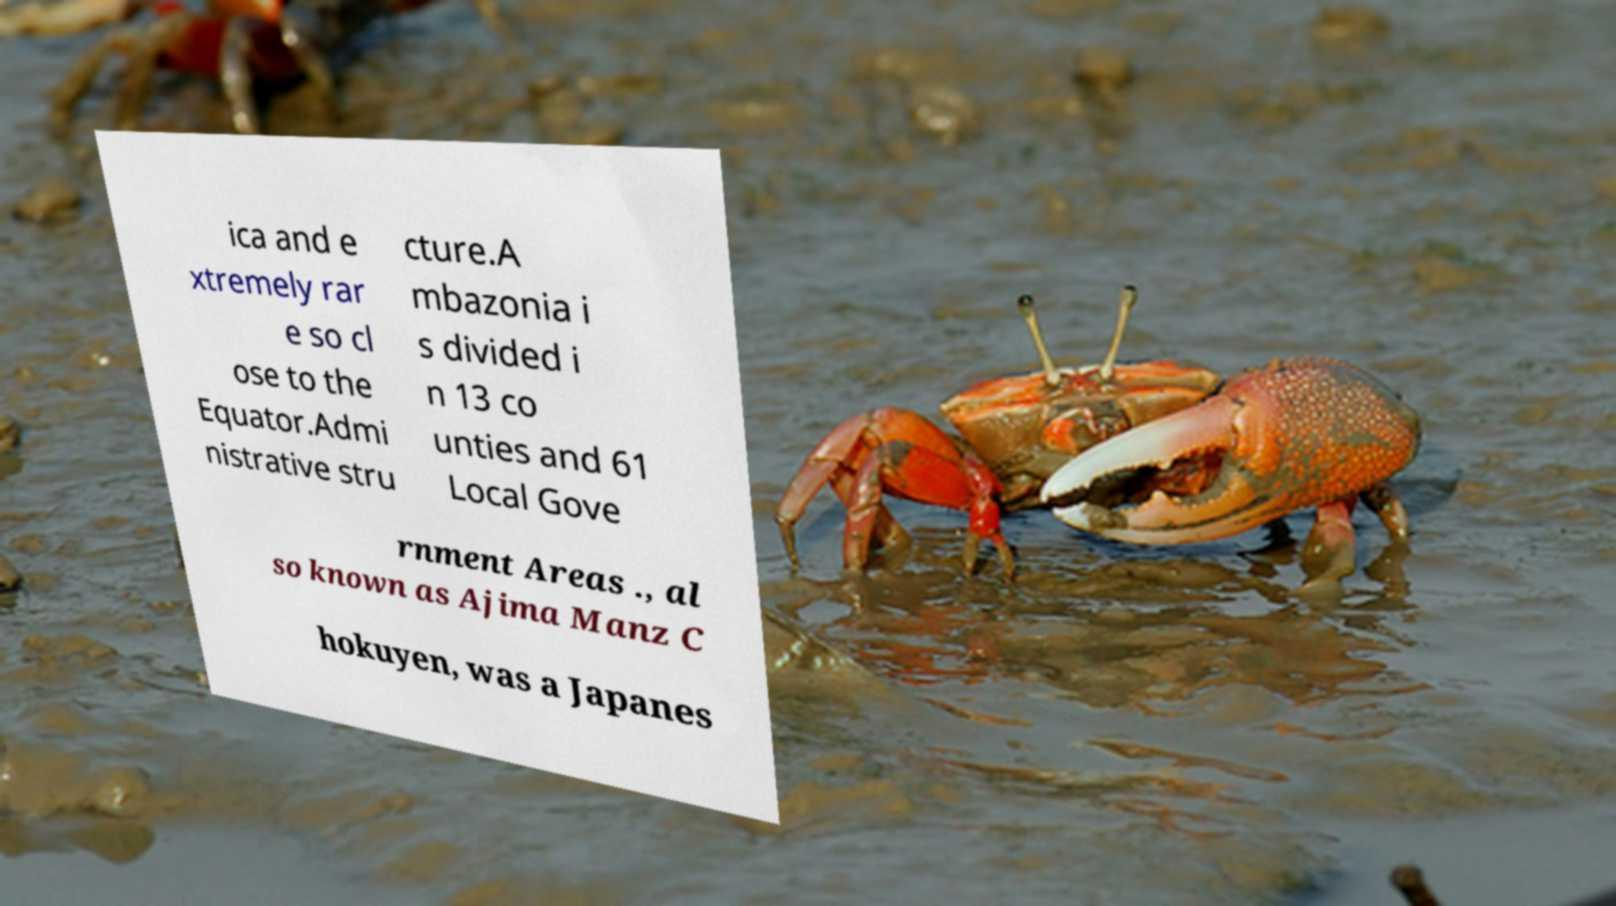For documentation purposes, I need the text within this image transcribed. Could you provide that? ica and e xtremely rar e so cl ose to the Equator.Admi nistrative stru cture.A mbazonia i s divided i n 13 co unties and 61 Local Gove rnment Areas ., al so known as Ajima Manz C hokuyen, was a Japanes 